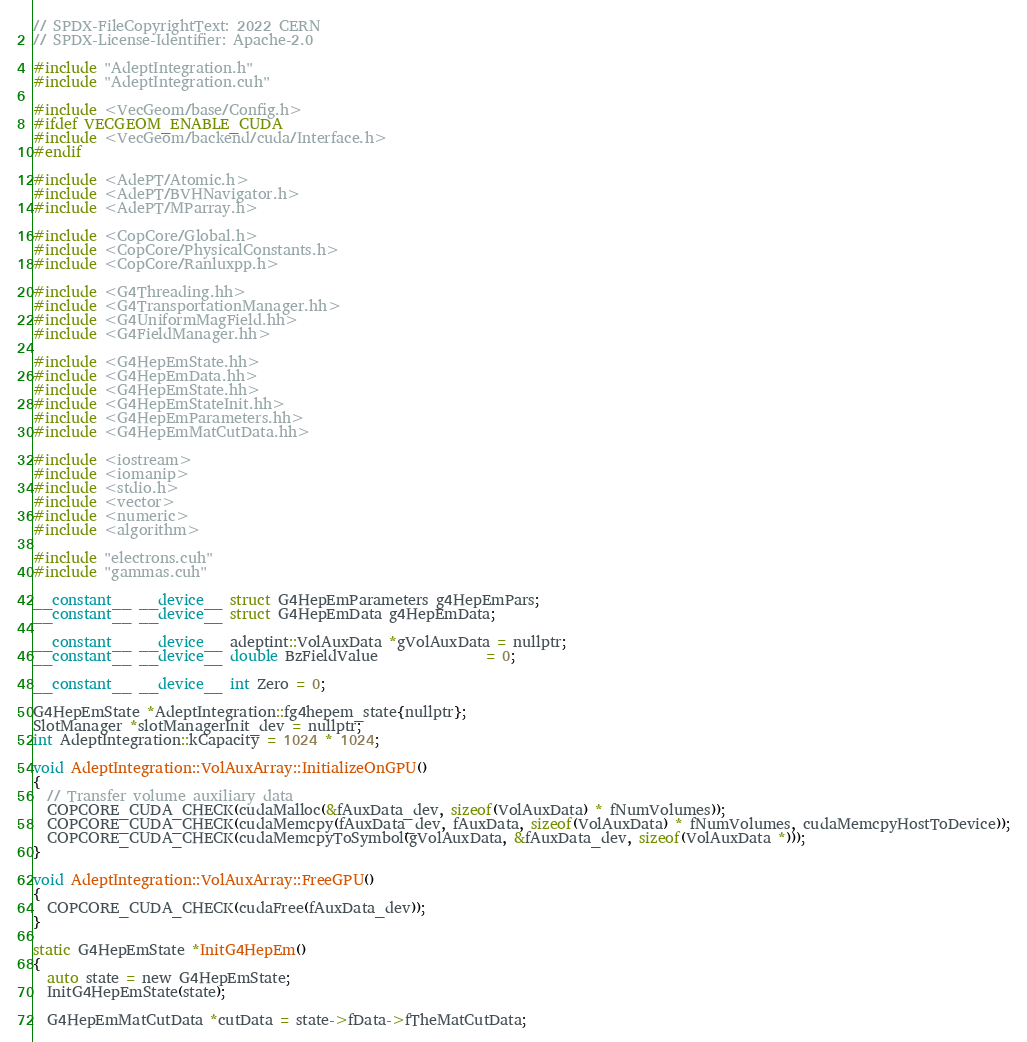Convert code to text. <code><loc_0><loc_0><loc_500><loc_500><_Cuda_>// SPDX-FileCopyrightText: 2022 CERN
// SPDX-License-Identifier: Apache-2.0

#include "AdeptIntegration.h"
#include "AdeptIntegration.cuh"

#include <VecGeom/base/Config.h>
#ifdef VECGEOM_ENABLE_CUDA
#include <VecGeom/backend/cuda/Interface.h>
#endif

#include <AdePT/Atomic.h>
#include <AdePT/BVHNavigator.h>
#include <AdePT/MParray.h>

#include <CopCore/Global.h>
#include <CopCore/PhysicalConstants.h>
#include <CopCore/Ranluxpp.h>

#include <G4Threading.hh>
#include <G4TransportationManager.hh>
#include <G4UniformMagField.hh>
#include <G4FieldManager.hh>

#include <G4HepEmState.hh>
#include <G4HepEmData.hh>
#include <G4HepEmState.hh>
#include <G4HepEmStateInit.hh>
#include <G4HepEmParameters.hh>
#include <G4HepEmMatCutData.hh>

#include <iostream>
#include <iomanip>
#include <stdio.h>
#include <vector>
#include <numeric>
#include <algorithm>

#include "electrons.cuh"
#include "gammas.cuh"

__constant__ __device__ struct G4HepEmParameters g4HepEmPars;
__constant__ __device__ struct G4HepEmData g4HepEmData;

__constant__ __device__ adeptint::VolAuxData *gVolAuxData = nullptr;
__constant__ __device__ double BzFieldValue               = 0;

__constant__ __device__ int Zero = 0;

G4HepEmState *AdeptIntegration::fg4hepem_state{nullptr};
SlotManager *slotManagerInit_dev = nullptr;
int AdeptIntegration::kCapacity = 1024 * 1024;

void AdeptIntegration::VolAuxArray::InitializeOnGPU()
{
  // Transfer volume auxiliary data
  COPCORE_CUDA_CHECK(cudaMalloc(&fAuxData_dev, sizeof(VolAuxData) * fNumVolumes));
  COPCORE_CUDA_CHECK(cudaMemcpy(fAuxData_dev, fAuxData, sizeof(VolAuxData) * fNumVolumes, cudaMemcpyHostToDevice));
  COPCORE_CUDA_CHECK(cudaMemcpyToSymbol(gVolAuxData, &fAuxData_dev, sizeof(VolAuxData *)));
}

void AdeptIntegration::VolAuxArray::FreeGPU()
{
  COPCORE_CUDA_CHECK(cudaFree(fAuxData_dev));
}

static G4HepEmState *InitG4HepEm()
{
  auto state = new G4HepEmState;
  InitG4HepEmState(state);

  G4HepEmMatCutData *cutData = state->fData->fTheMatCutData;</code> 